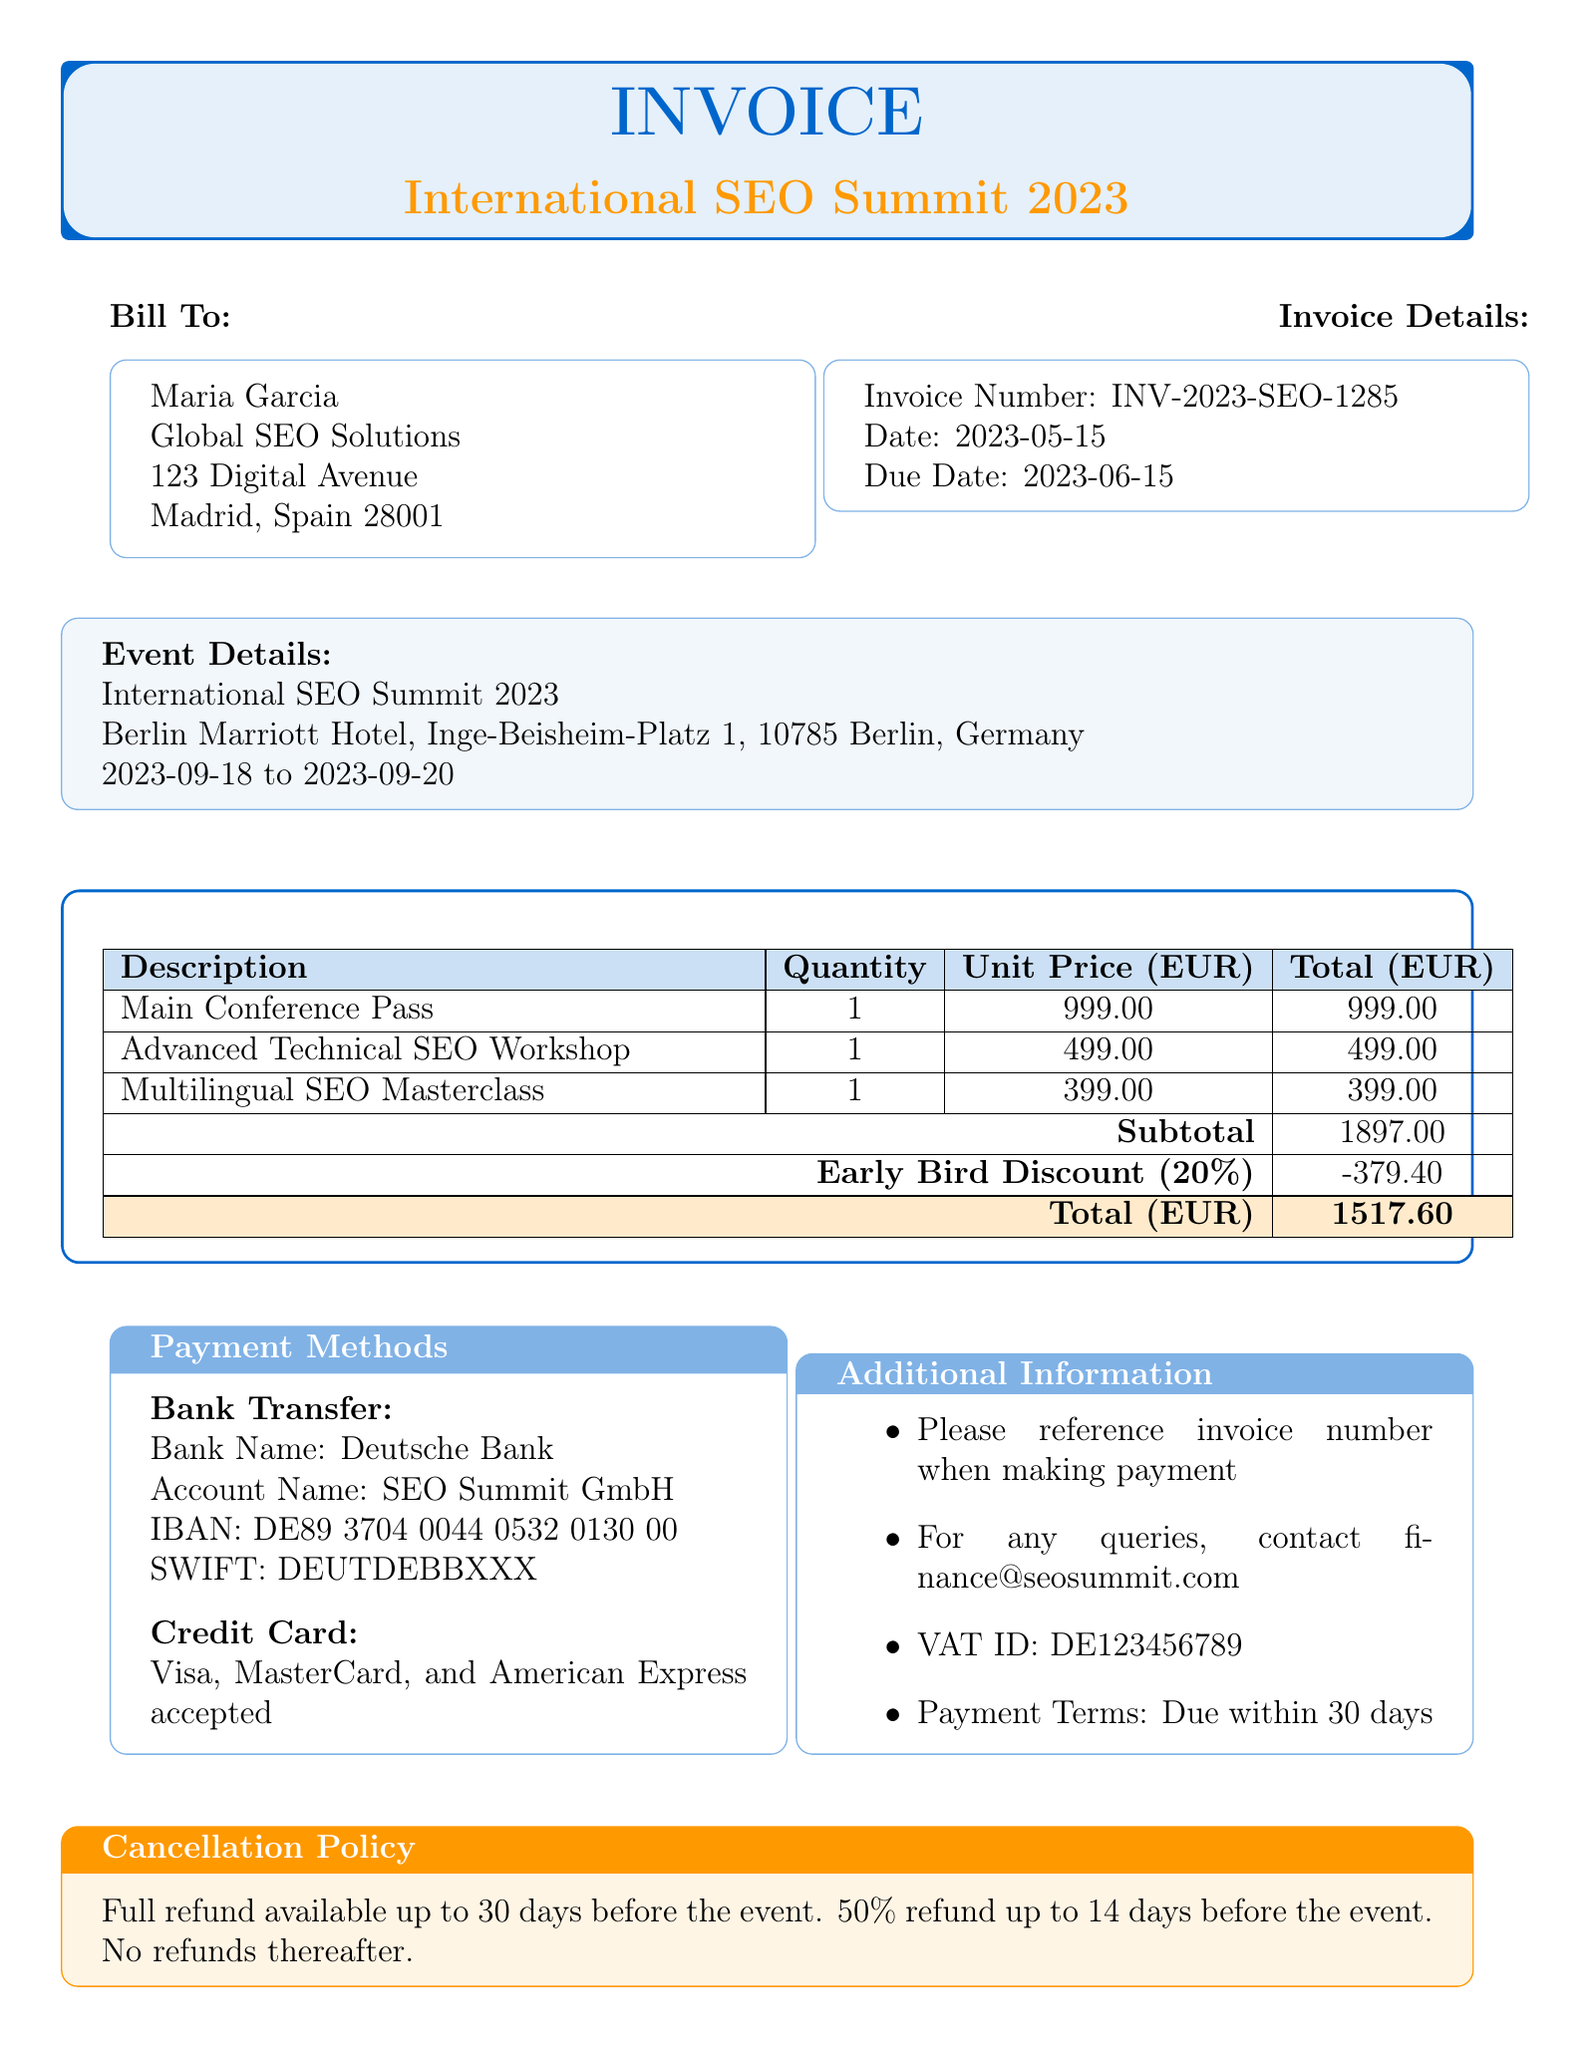What is the invoice number? The invoice number is a unique identifier for the document and can be found in the invoice details section.
Answer: INV-2023-SEO-1285 Who is the invoice billed to? The "Bill To" section specifies the name of the individual and their company associated with the invoice.
Answer: Maria Garcia What is the subtotal amount? The subtotal is the sum of all line item totals before any discounts are applied.
Answer: 1897.00 What is the amount of the early bird discount? The document lists the early bird discount as a negative amount indicating a deduction from the subtotal.
Answer: -379.40 What is the total amount due? The total amount is calculated after applying the early bird discount to the subtotal.
Answer: 1517.60 Where is the event located? The event details section provides the location of the conference.
Answer: Berlin Marriott Hotel, Inge-Beisheim-Platz 1, 10785 Berlin, Germany What are the payment methods accepted? The payment methods section outlines the types of payments that can be used to settle this invoice.
Answer: Bank Transfer, Credit Card What is the cancellation policy? This section describes the terms under which attendees can receive refunds based on their cancellation timing.
Answer: Full refund available up to 30 days before the event What benefits are included with registration? The included benefits section highlights what attendees receive as part of their registration fee.
Answer: Access to all keynote sessions, Networking events, Lunch and refreshments, Digital conference materials, 1-year subscription to SEO Summit online resources 